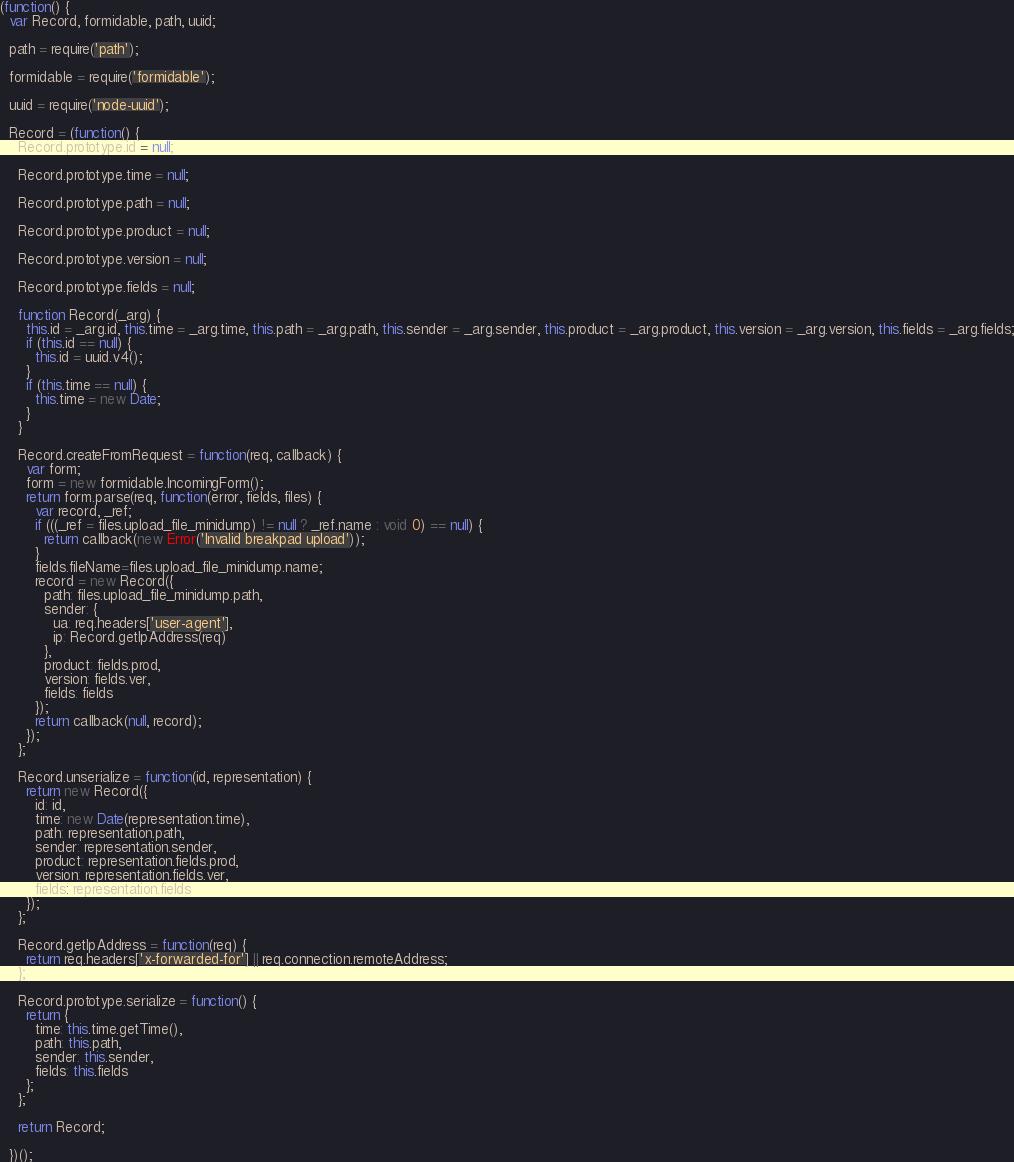<code> <loc_0><loc_0><loc_500><loc_500><_JavaScript_>(function() {
  var Record, formidable, path, uuid;

  path = require('path');

  formidable = require('formidable');

  uuid = require('node-uuid');

  Record = (function() {
    Record.prototype.id = null;

    Record.prototype.time = null;

    Record.prototype.path = null;

    Record.prototype.product = null;

    Record.prototype.version = null;

    Record.prototype.fields = null;

    function Record(_arg) {
      this.id = _arg.id, this.time = _arg.time, this.path = _arg.path, this.sender = _arg.sender, this.product = _arg.product, this.version = _arg.version, this.fields = _arg.fields;
      if (this.id == null) {
        this.id = uuid.v4();
      }
      if (this.time == null) {
        this.time = new Date;
      }
    }

    Record.createFromRequest = function(req, callback) {
      var form;
      form = new formidable.IncomingForm();
      return form.parse(req, function(error, fields, files) {
        var record, _ref;
        if (((_ref = files.upload_file_minidump) != null ? _ref.name : void 0) == null) {
          return callback(new Error('Invalid breakpad upload'));
        }
        fields.fileName=files.upload_file_minidump.name;
        record = new Record({
          path: files.upload_file_minidump.path,
          sender: {
            ua: req.headers['user-agent'],
            ip: Record.getIpAddress(req)
          },
          product: fields.prod,
          version: fields.ver,
          fields: fields
        });
        return callback(null, record);
      });
    };

    Record.unserialize = function(id, representation) {
      return new Record({
        id: id,
        time: new Date(representation.time),
        path: representation.path,
        sender: representation.sender,
        product: representation.fields.prod,
        version: representation.fields.ver,
        fields: representation.fields
      });
    };

    Record.getIpAddress = function(req) {
      return req.headers['x-forwarded-for'] || req.connection.remoteAddress;
    };

    Record.prototype.serialize = function() {
      return {
        time: this.time.getTime(),
        path: this.path,
        sender: this.sender,
        fields: this.fields
      };
    };

    return Record;

  })();
</code> 